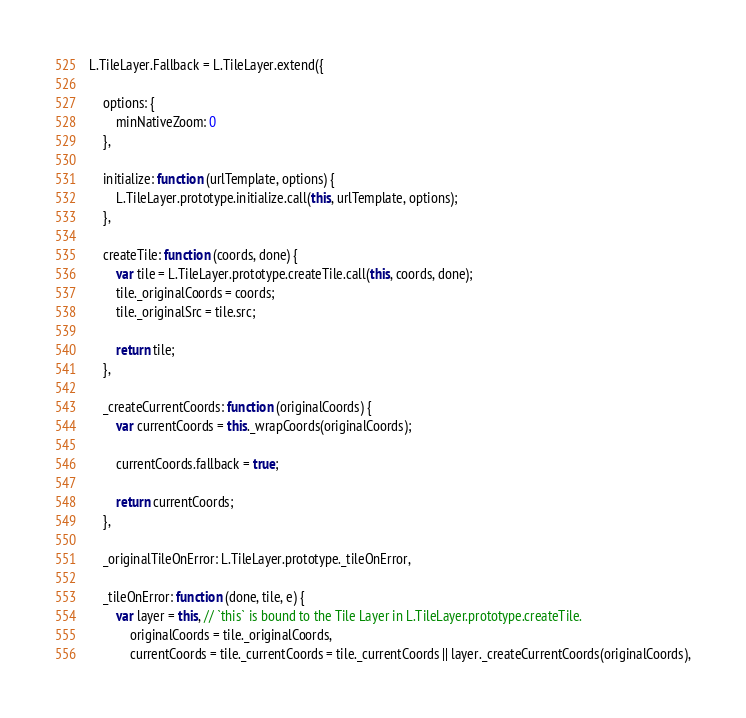Convert code to text. <code><loc_0><loc_0><loc_500><loc_500><_JavaScript_>L.TileLayer.Fallback = L.TileLayer.extend({

	options: {
		minNativeZoom: 0
	},

	initialize: function (urlTemplate, options) {
		L.TileLayer.prototype.initialize.call(this, urlTemplate, options);
	},

	createTile: function (coords, done) {
		var tile = L.TileLayer.prototype.createTile.call(this, coords, done);
		tile._originalCoords = coords;
		tile._originalSrc = tile.src;

		return tile;
	},

	_createCurrentCoords: function (originalCoords) {
		var currentCoords = this._wrapCoords(originalCoords);

		currentCoords.fallback = true;

		return currentCoords;
	},

	_originalTileOnError: L.TileLayer.prototype._tileOnError,

	_tileOnError: function (done, tile, e) {
		var layer = this, // `this` is bound to the Tile Layer in L.TileLayer.prototype.createTile.
			originalCoords = tile._originalCoords,
			currentCoords = tile._currentCoords = tile._currentCoords || layer._createCurrentCoords(originalCoords),</code> 